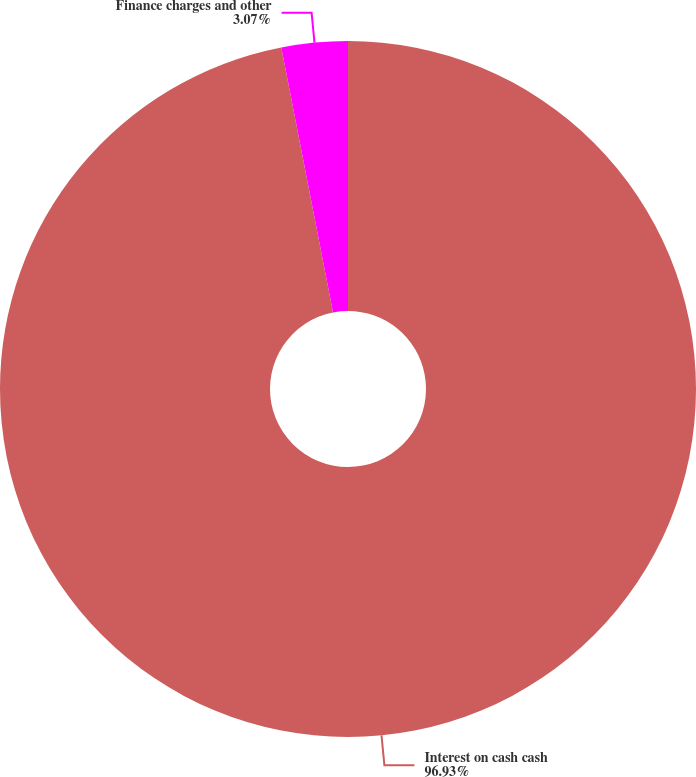<chart> <loc_0><loc_0><loc_500><loc_500><pie_chart><fcel>Interest on cash cash<fcel>Finance charges and other<nl><fcel>96.93%<fcel>3.07%<nl></chart> 